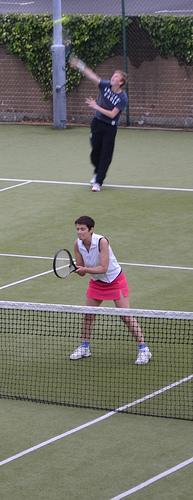How many people are in this picture?
Give a very brief answer. 2. 